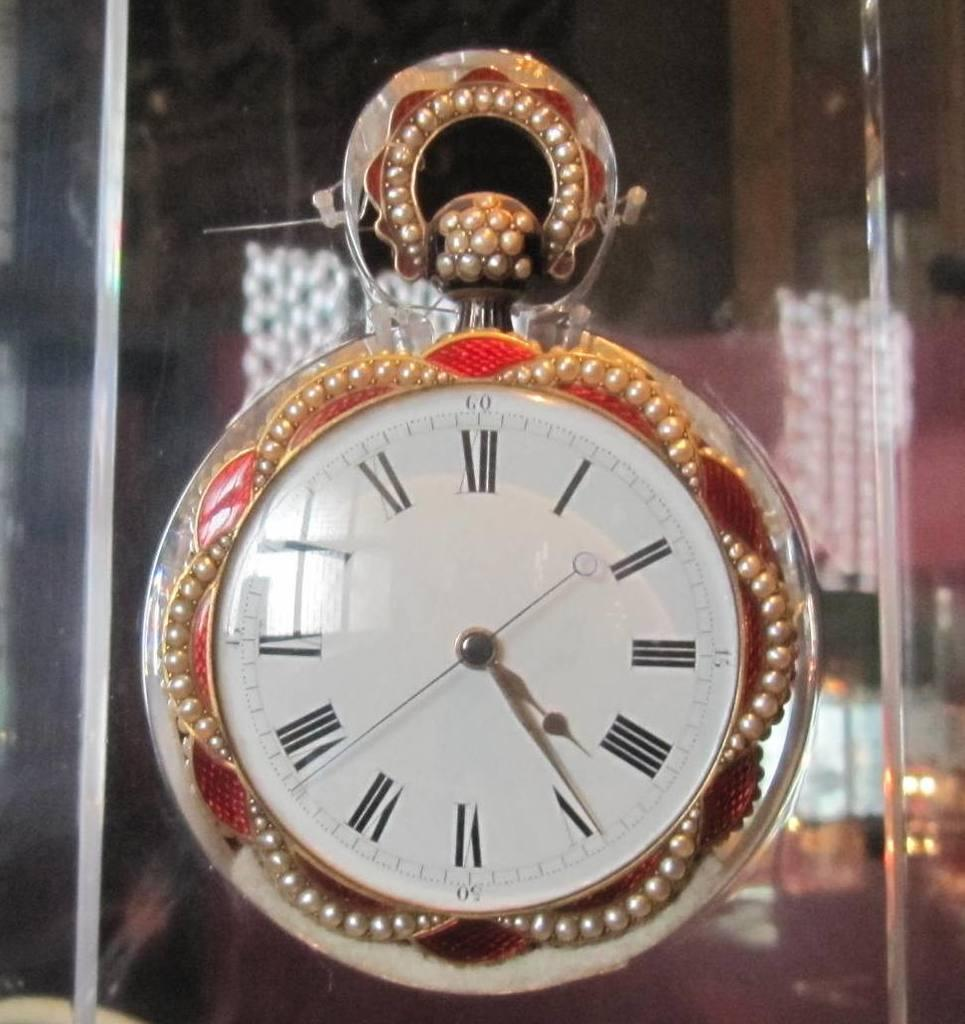What object in the image tells the time? There is a clock in the image that tells the time. What additional feature can be seen on the clock? The clock has round balls attached to it. Can you describe the background of the image? The background of the image is blurred. What type of shock can be seen affecting the marble in the image? There is no marble present in the image, and therefore no shock can be observed. 